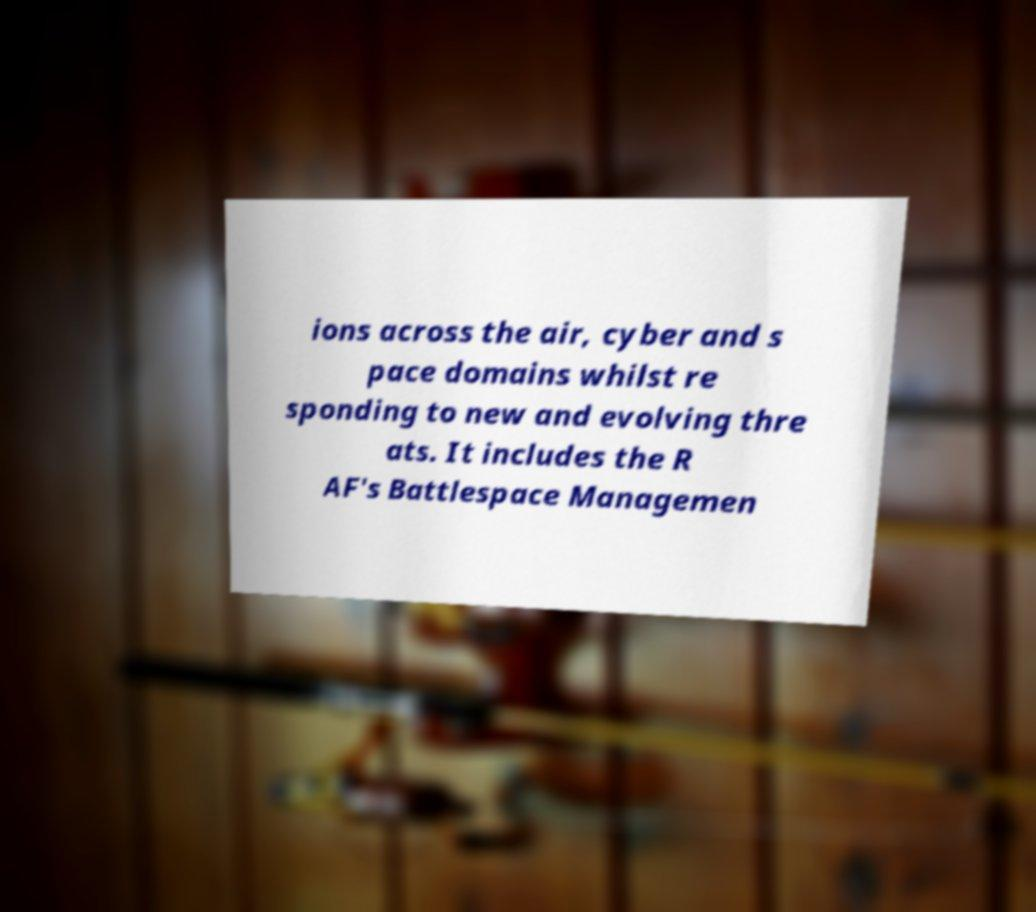Can you read and provide the text displayed in the image?This photo seems to have some interesting text. Can you extract and type it out for me? ions across the air, cyber and s pace domains whilst re sponding to new and evolving thre ats. It includes the R AF's Battlespace Managemen 